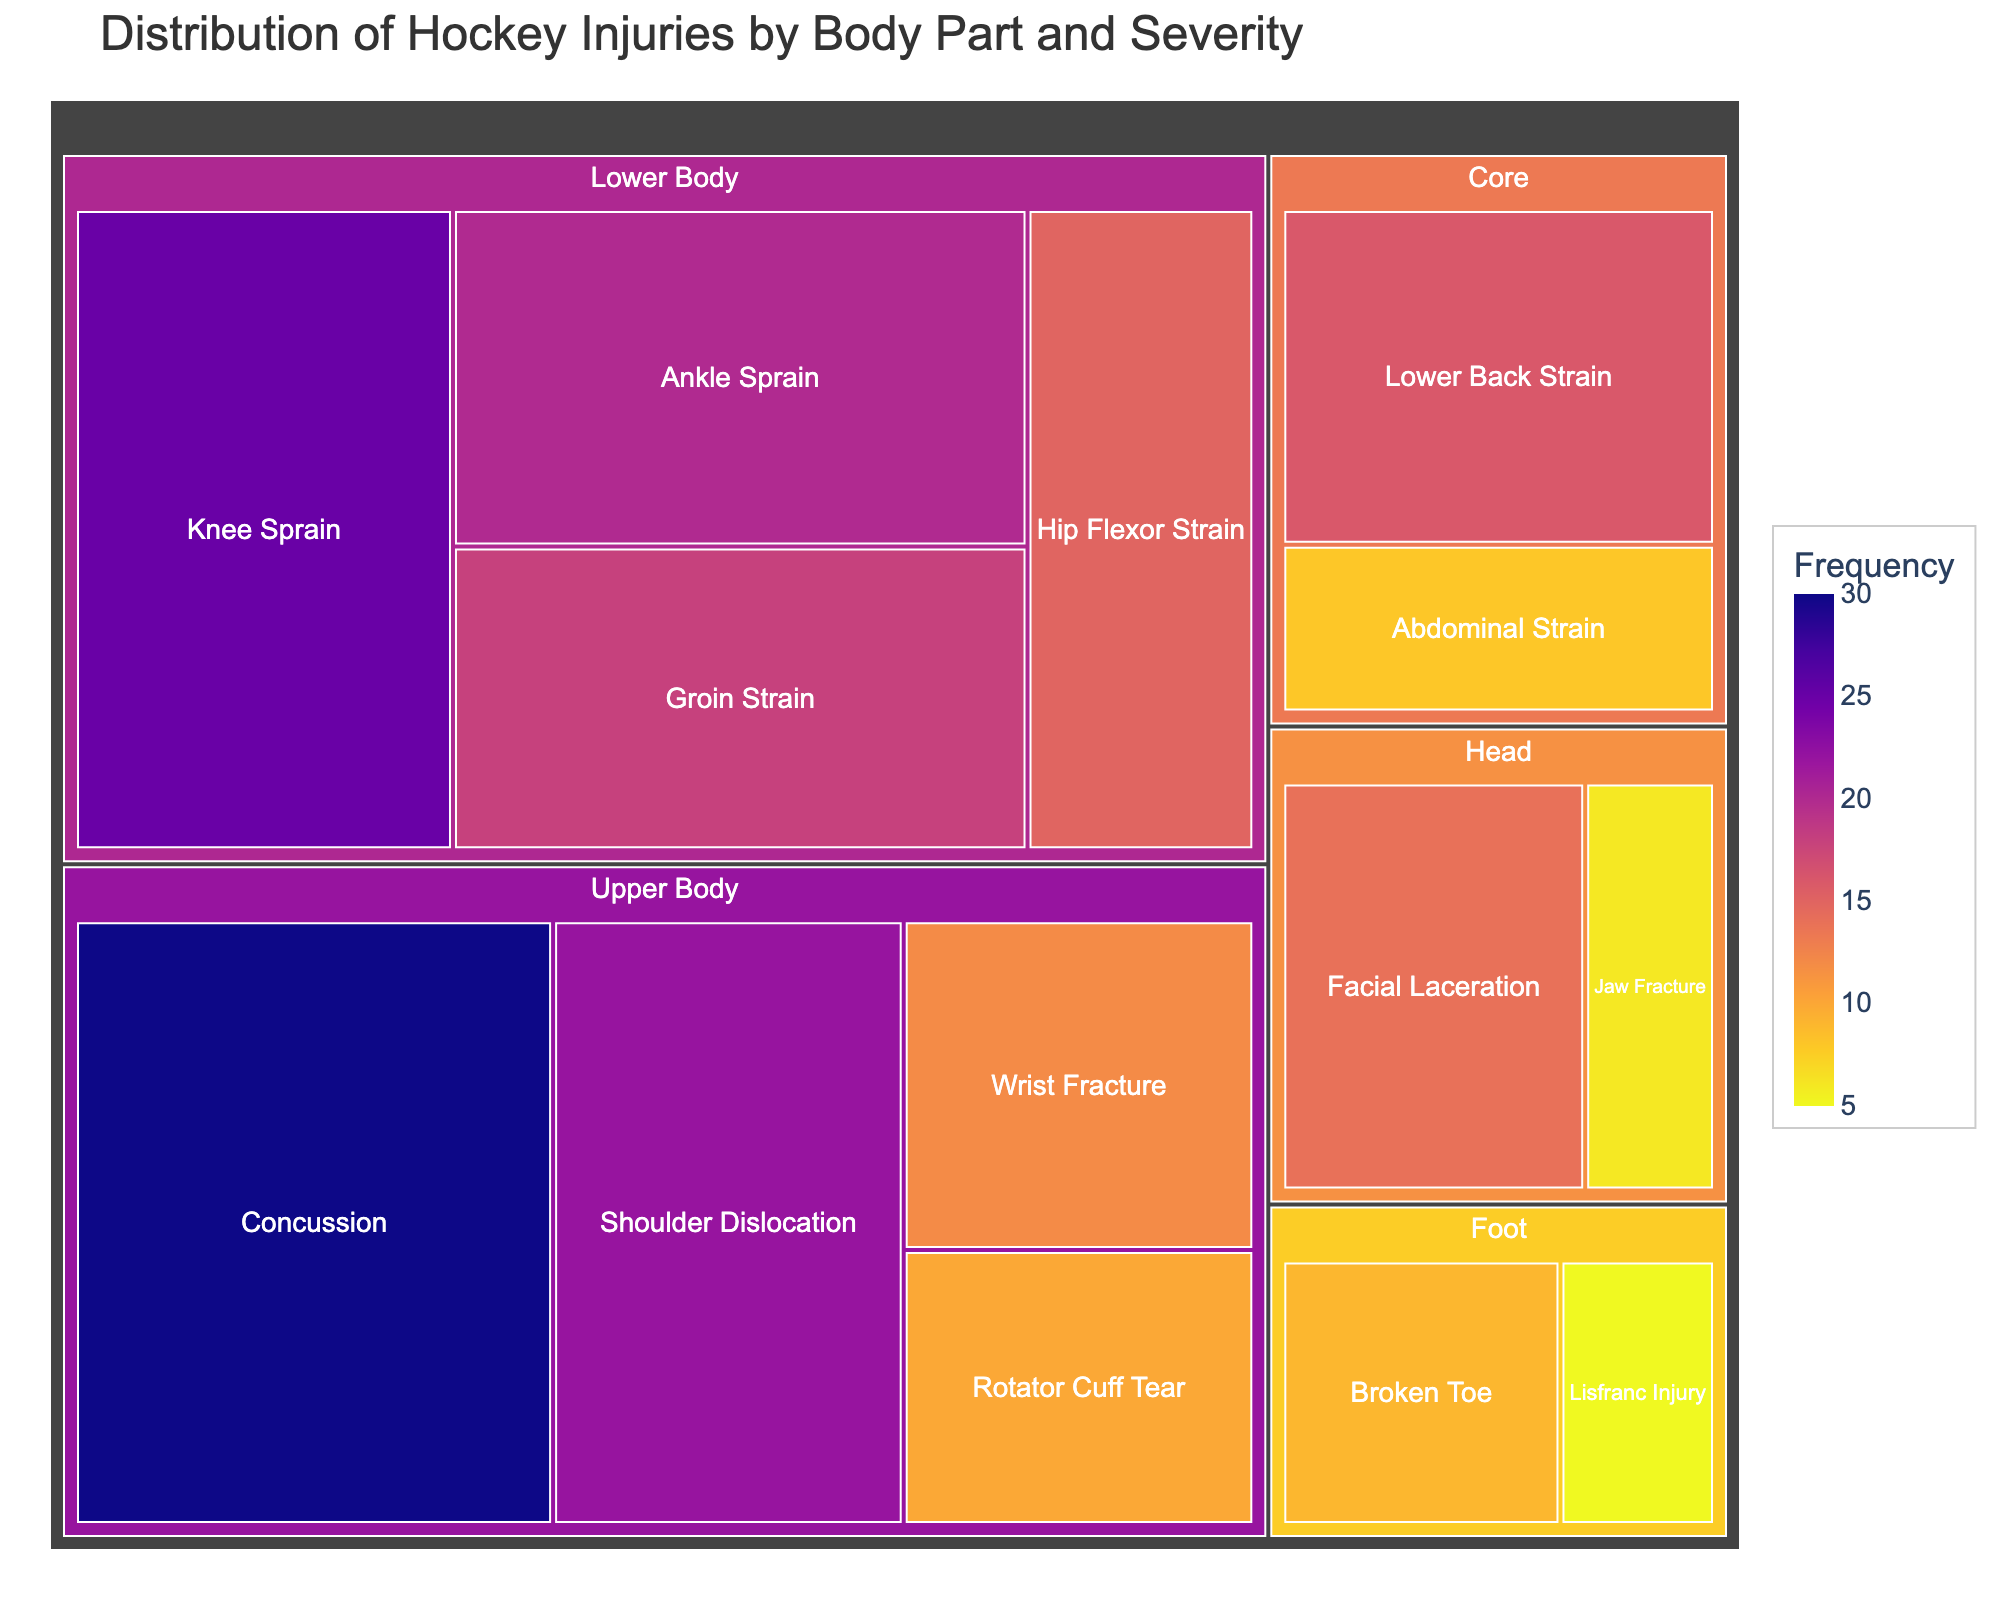What is the most frequent injury type? The concussion injury type under Upper Body has the highest frequency value, which is 30, visible by the size and the hover data showing "Frequency: 30."
Answer: Concussion How many injury types are there in the Lower Body category? The Lower Body category includes four types: Knee Sprain, Ankle Sprain, Groin Strain, and Hip Flexor Strain.
Answer: 4 Which injury type in the Head category has a higher frequency? The Facial Laceration has a frequency of 14, while Jaw Fracture has a frequency of 6. Thus, Facial Laceration has a higher frequency.
Answer: Facial Laceration What is the total frequency of injuries in the Core category? By summing the frequencies of the Core injury types: Lower Back Strain (16) and Abdominal Strain (8), the total frequency is 16 + 8 = 24.
Answer: 24 Compare the frequency of Shoulder Dislocation and Wrist Fracture. Which one is higher, and by how much? Shoulder Dislocation has a frequency of 22, and Wrist Fracture has a frequency of 12. The difference is 22 - 12 = 10.
Answer: Shoulder Dislocation by 10 What is the frequency of the least common injury type in the Foot category? The Lisfranc Injury in the Foot category has the lowest frequency of 5, compared to Broken Toe's frequency of 9.
Answer: 5 Which category has the highest total injury frequency? Summing the frequencies for each category: Lower Body (25 + 20 + 18 + 15 = 78), Upper Body (22 + 30 + 12 + 10 = 74), Core (16 + 8 = 24), Head (14 + 6 = 20), Foot (9 + 5 = 14), the Lower Body category has the highest total frequency, which is 78.
Answer: Lower Body What is the average frequency of injuries in the Upper Body category? The frequencies in the Upper Body category are 22, 30, 12, and 10. Their sum is 22 + 30 + 12 + 10 = 74. The average is 74 / 4 = 18.5.
Answer: 18.5 How does the frequency of Groin Strain compare to Hip Flexor Strain in the Lower Body category? Groin Strain has a frequency of 18, and Hip Flexor Strain has a frequency of 15. Therefore, Groin Strain is more frequent than Hip Flexor Strain.
Answer: Groin Strain is more frequent Which injury type has the smallest frequency in the entire dataset? By visually identifying the smallest section in the Treemap and checking the frequency values, Lisfranc Injury in the Foot category, with a frequency of 5, is the least frequent.
Answer: Lisfranc Injury 